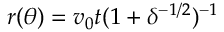Convert formula to latex. <formula><loc_0><loc_0><loc_500><loc_500>r ( \theta ) = v _ { 0 } t ( 1 + \delta ^ { - 1 / 2 } ) ^ { - 1 }</formula> 